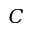Convert formula to latex. <formula><loc_0><loc_0><loc_500><loc_500>C</formula> 